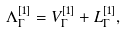<formula> <loc_0><loc_0><loc_500><loc_500>\Lambda _ { \Gamma } ^ { [ 1 ] } = V _ { \Gamma } ^ { [ 1 ] } + L _ { \Gamma } ^ { [ 1 ] } ,</formula> 